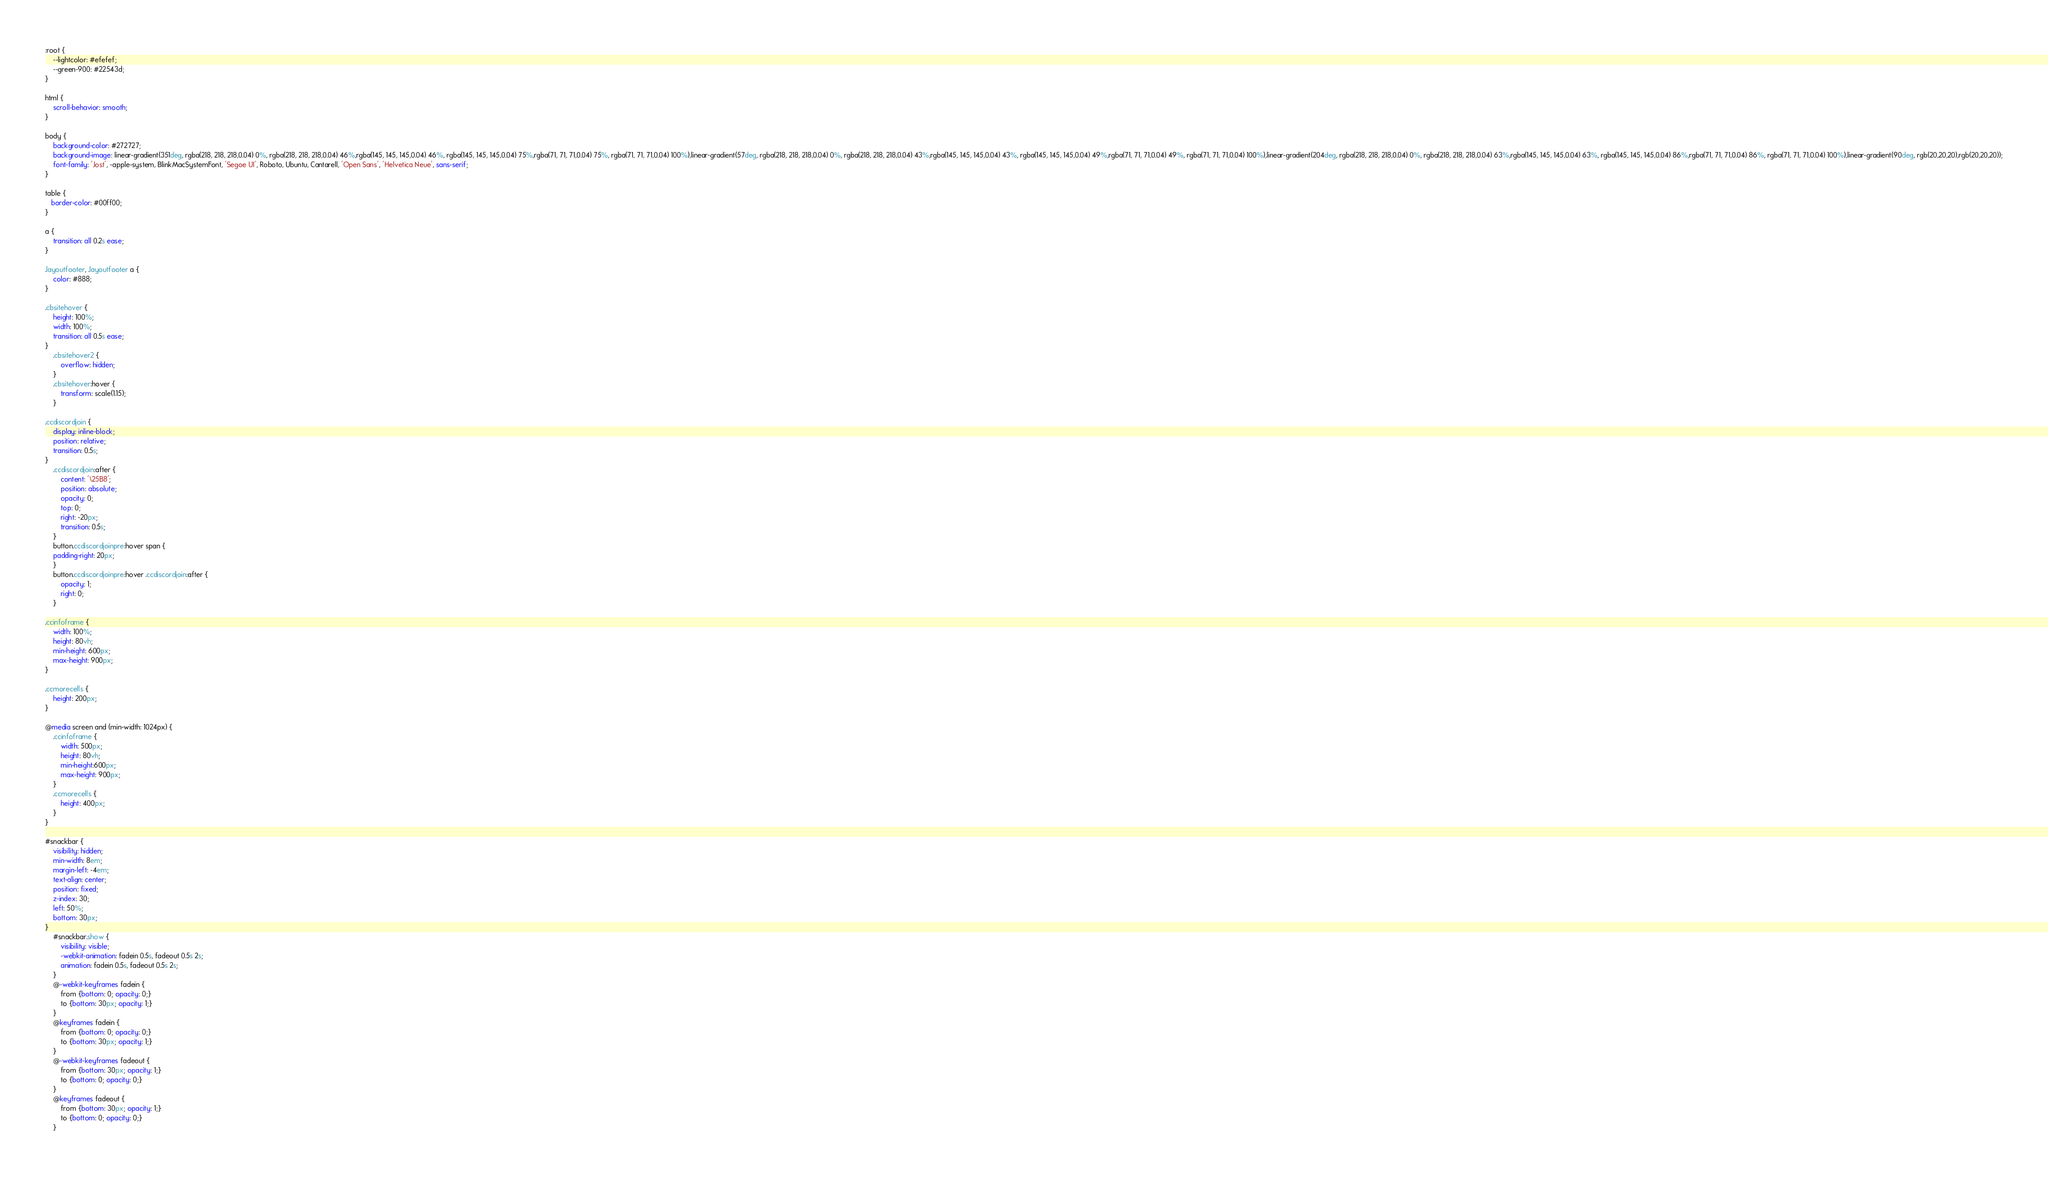Convert code to text. <code><loc_0><loc_0><loc_500><loc_500><_CSS_>:root {
    --lightcolor: #efefef;
    --green-900: #22543d;
}

html {
    scroll-behavior: smooth;
}

body {
    background-color: #272727;
    background-image: linear-gradient(351deg, rgba(218, 218, 218,0.04) 0%, rgba(218, 218, 218,0.04) 46%,rgba(145, 145, 145,0.04) 46%, rgba(145, 145, 145,0.04) 75%,rgba(71, 71, 71,0.04) 75%, rgba(71, 71, 71,0.04) 100%),linear-gradient(57deg, rgba(218, 218, 218,0.04) 0%, rgba(218, 218, 218,0.04) 43%,rgba(145, 145, 145,0.04) 43%, rgba(145, 145, 145,0.04) 49%,rgba(71, 71, 71,0.04) 49%, rgba(71, 71, 71,0.04) 100%),linear-gradient(204deg, rgba(218, 218, 218,0.04) 0%, rgba(218, 218, 218,0.04) 63%,rgba(145, 145, 145,0.04) 63%, rgba(145, 145, 145,0.04) 86%,rgba(71, 71, 71,0.04) 86%, rgba(71, 71, 71,0.04) 100%),linear-gradient(90deg, rgb(20,20,20),rgb(20,20,20));
    font-family: 'Jost', -apple-system, BlinkMacSystemFont, 'Segoe UI', Roboto, Ubuntu, Cantarell, 'Open Sans', 'Helvetica Neue', sans-serif;
}

table {
   border-color: #00ff00;
}

a {
    transition: all 0.2s ease;
}

.layoutfooter, .layoutfooter a {
    color: #888;
}

.cbsitehover {
    height: 100%;
    width: 100%;
    transition: all 0.5s ease;
}
    .cbsitehover2 {
        overflow: hidden;
    }
    .cbsitehover:hover {
        transform: scale(1.15);
    }

.ccdiscordjoin {
    display: inline-block;
    position: relative;
    transition: 0.5s;
}
    .ccdiscordjoin:after {
        content: '\25B8';
        position: absolute;
        opacity: 0;
        top: 0;
        right: -20px;
        transition: 0.5s;
    }
    button.ccdiscordjoinpre:hover span {
    padding-right: 20px;
    }
    button.ccdiscordjoinpre:hover .ccdiscordjoin:after {
        opacity: 1;
        right: 0;
    }

.ccinfoframe {
    width: 100%;
    height: 80vh;
    min-height: 600px;
    max-height: 900px;
}

.ccmorecells {
    height: 200px;
}

@media screen and (min-width: 1024px) {
    .ccinfoframe {
        width: 500px;
        height: 80vh;
        min-height:600px;
        max-height: 900px;
    }
    .ccmorecells {
        height: 400px;
    }
}

#snackbar {
    visibility: hidden;
    min-width: 8em;
    margin-left: -4em;
    text-align: center;
    position: fixed;
    z-index: 30;
    left: 50%;
    bottom: 30px;
}
    #snackbar.show {
        visibility: visible;
        -webkit-animation: fadein 0.5s, fadeout 0.5s 2s;
        animation: fadein 0.5s, fadeout 0.5s 2s;
    }
    @-webkit-keyframes fadein {
        from {bottom: 0; opacity: 0;} 
        to {bottom: 30px; opacity: 1;}
    }
    @keyframes fadein {
        from {bottom: 0; opacity: 0;}
        to {bottom: 30px; opacity: 1;}
    }
    @-webkit-keyframes fadeout {
        from {bottom: 30px; opacity: 1;} 
        to {bottom: 0; opacity: 0;}
    }
    @keyframes fadeout {
        from {bottom: 30px; opacity: 1;}
        to {bottom: 0; opacity: 0;}
    }
</code> 